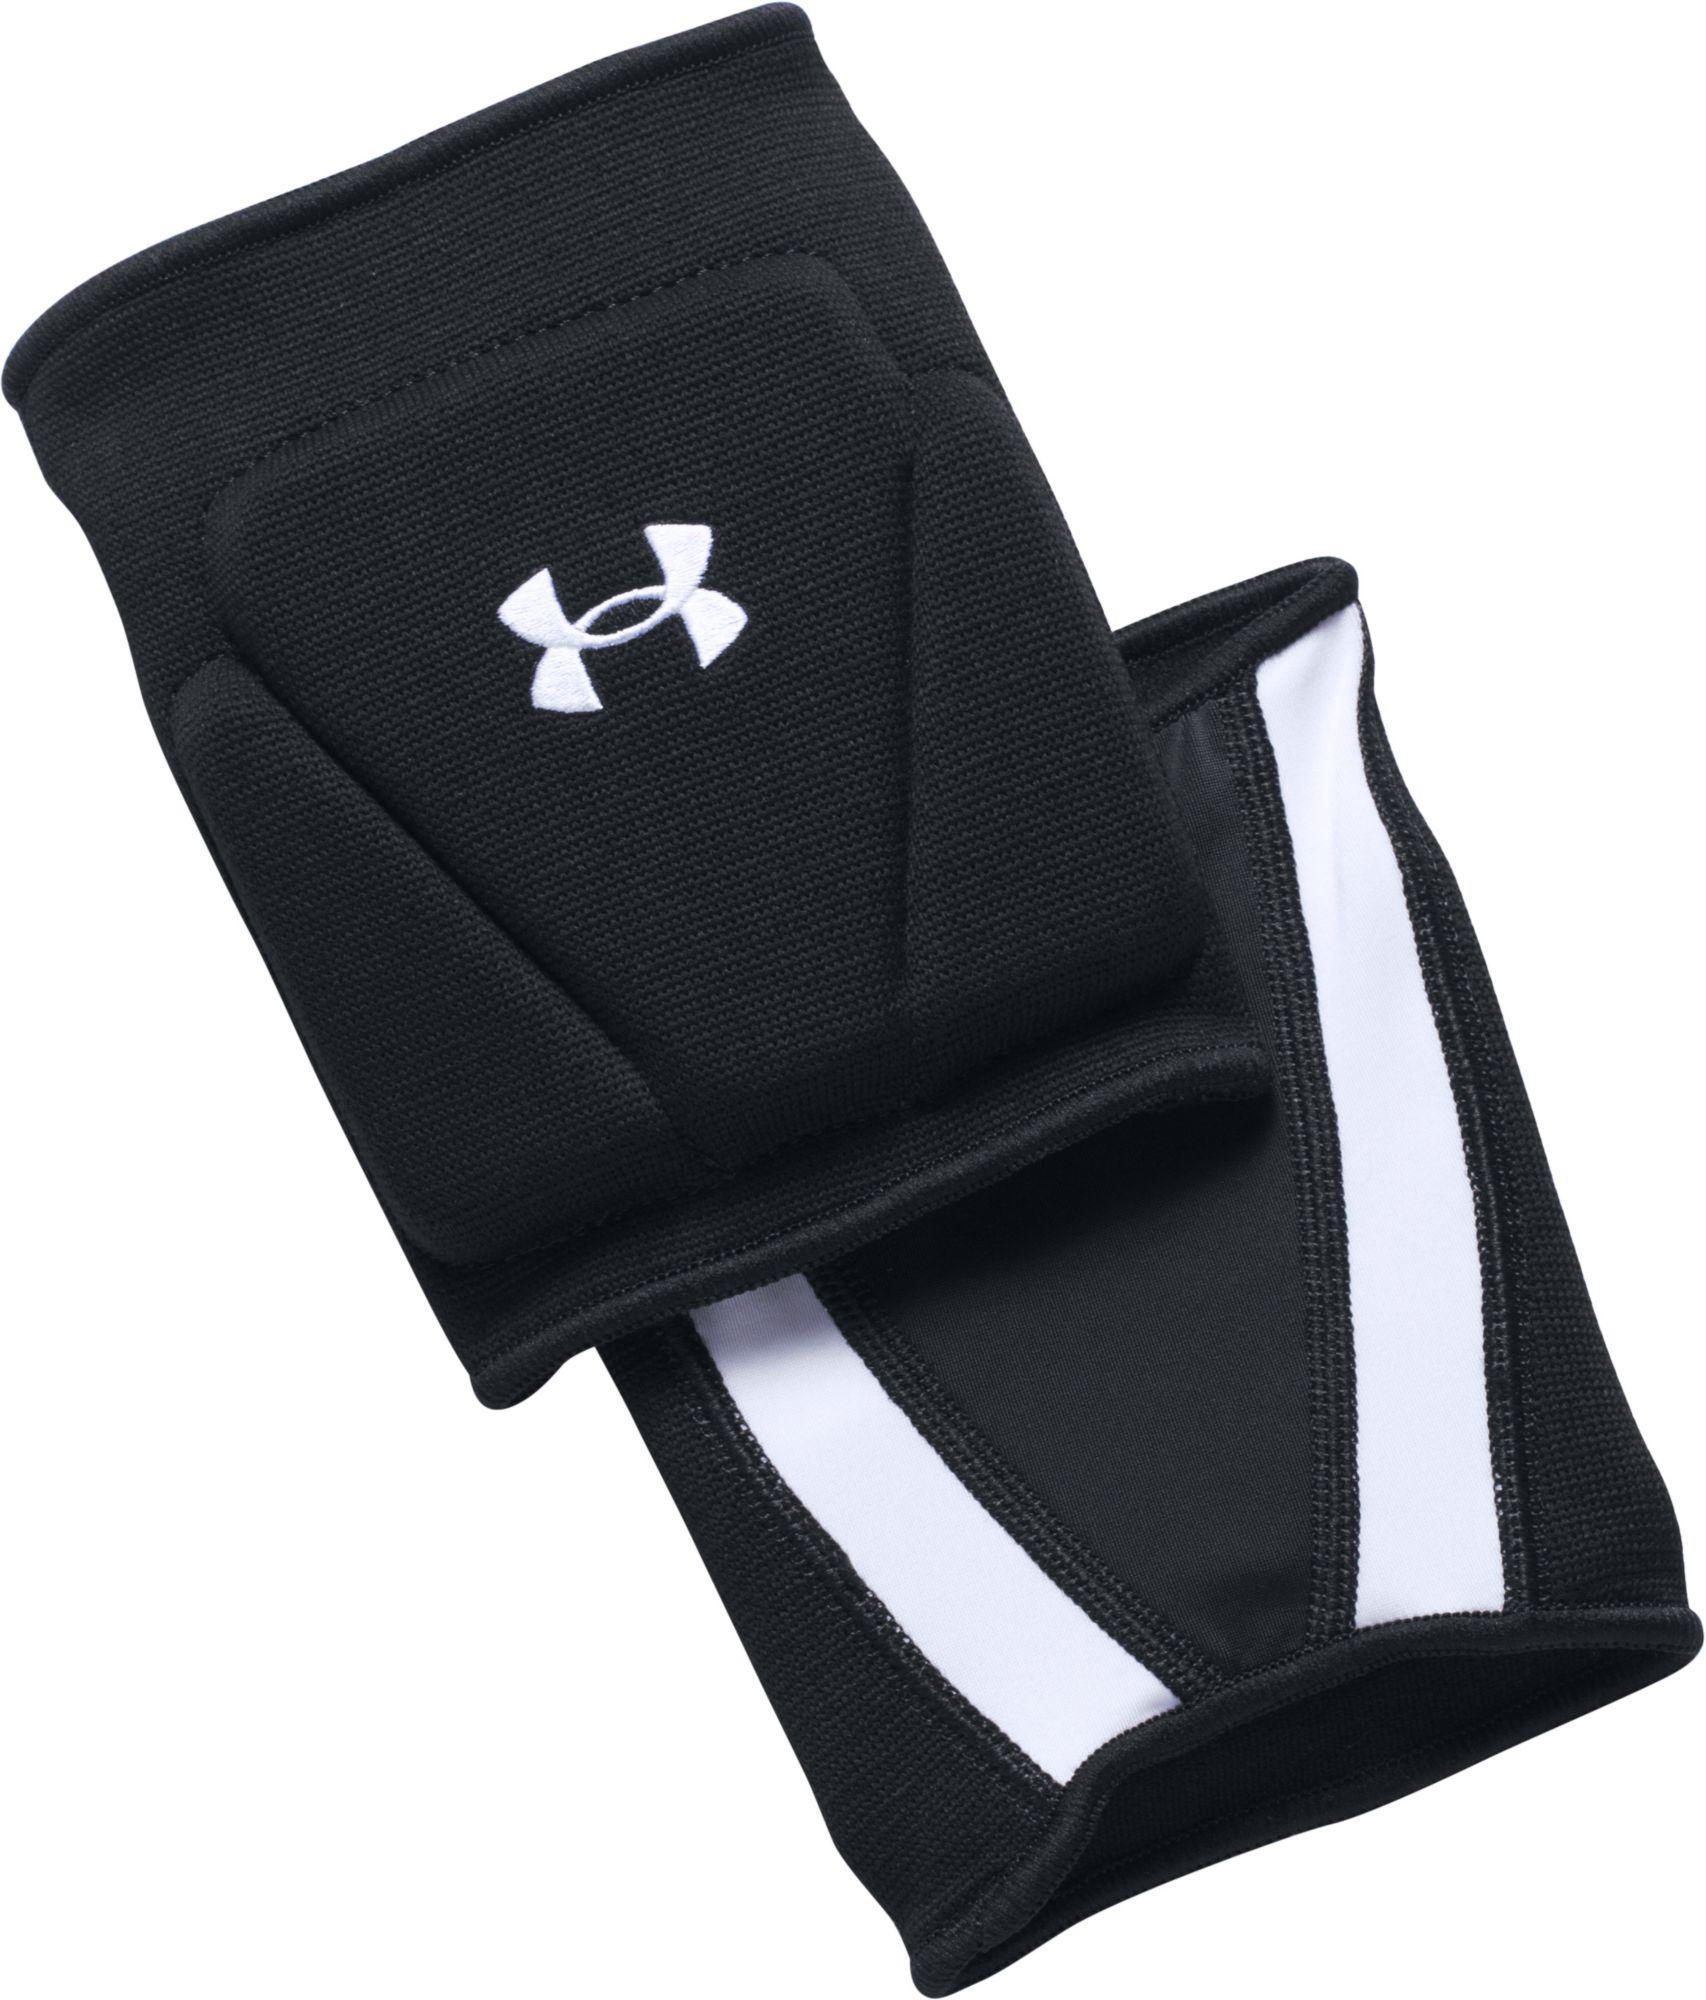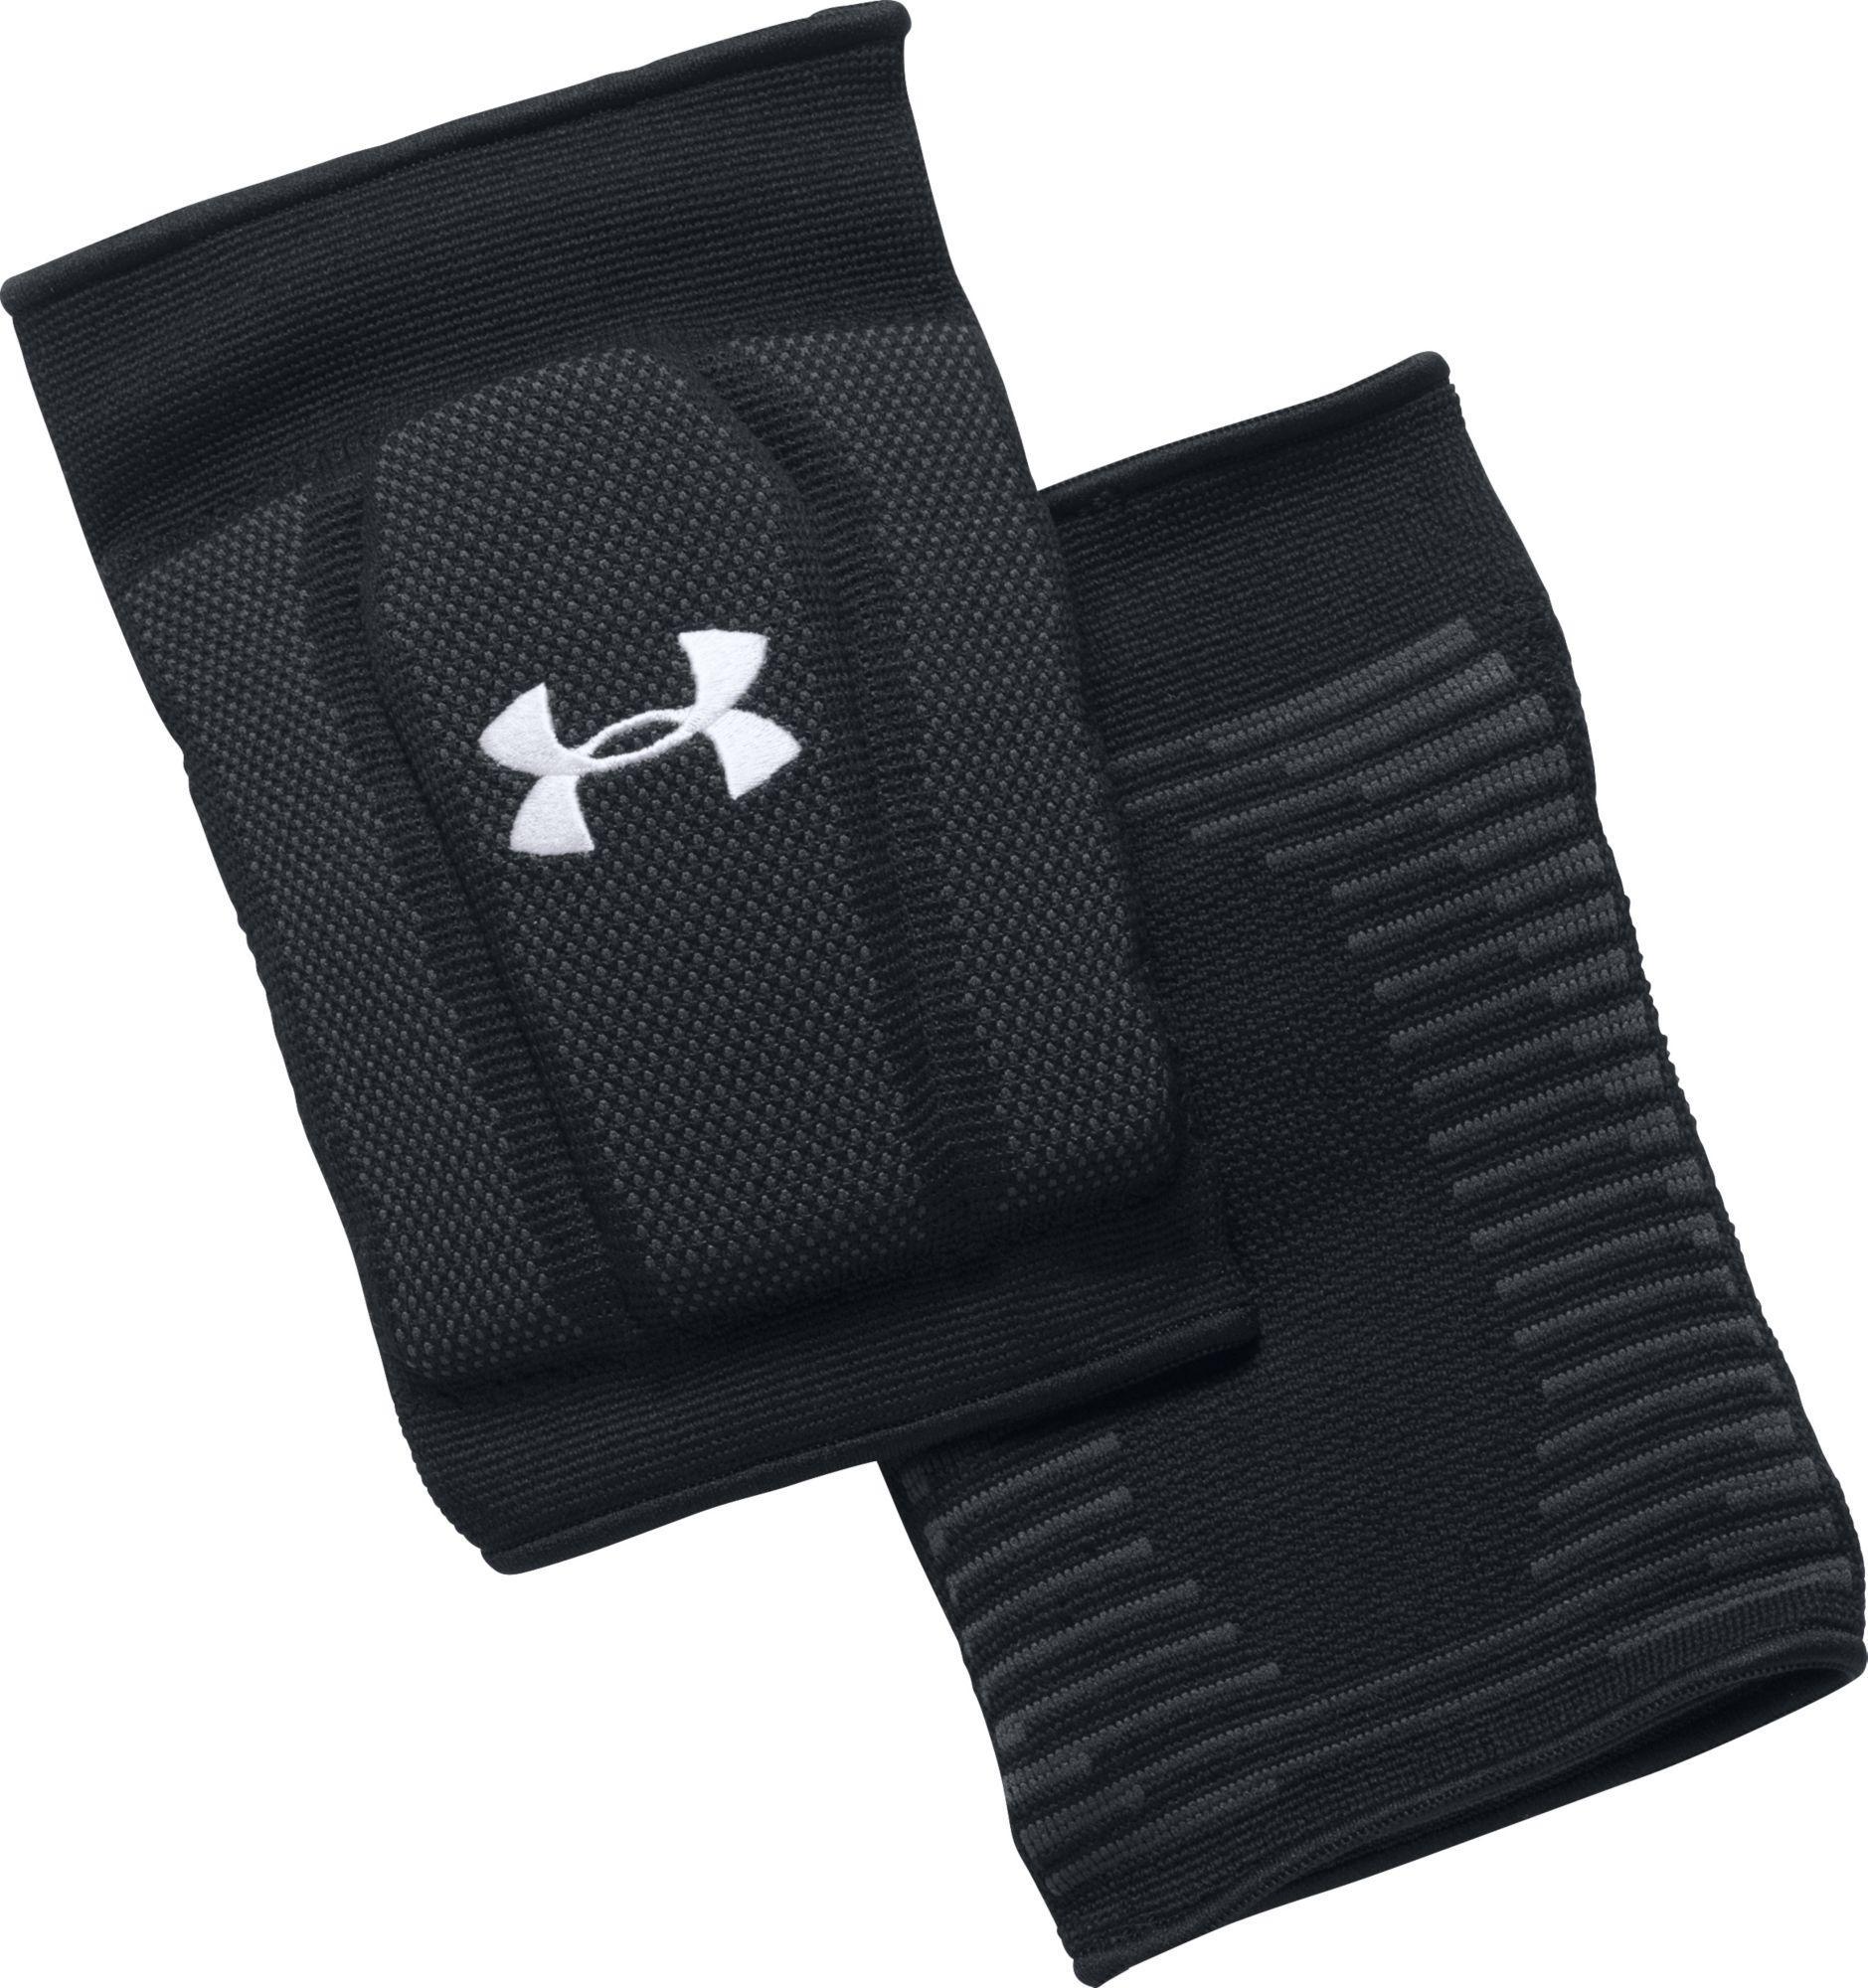The first image is the image on the left, the second image is the image on the right. Assess this claim about the two images: "Together, the images include both white knee pads and black knee pads only.". Correct or not? Answer yes or no. No. 